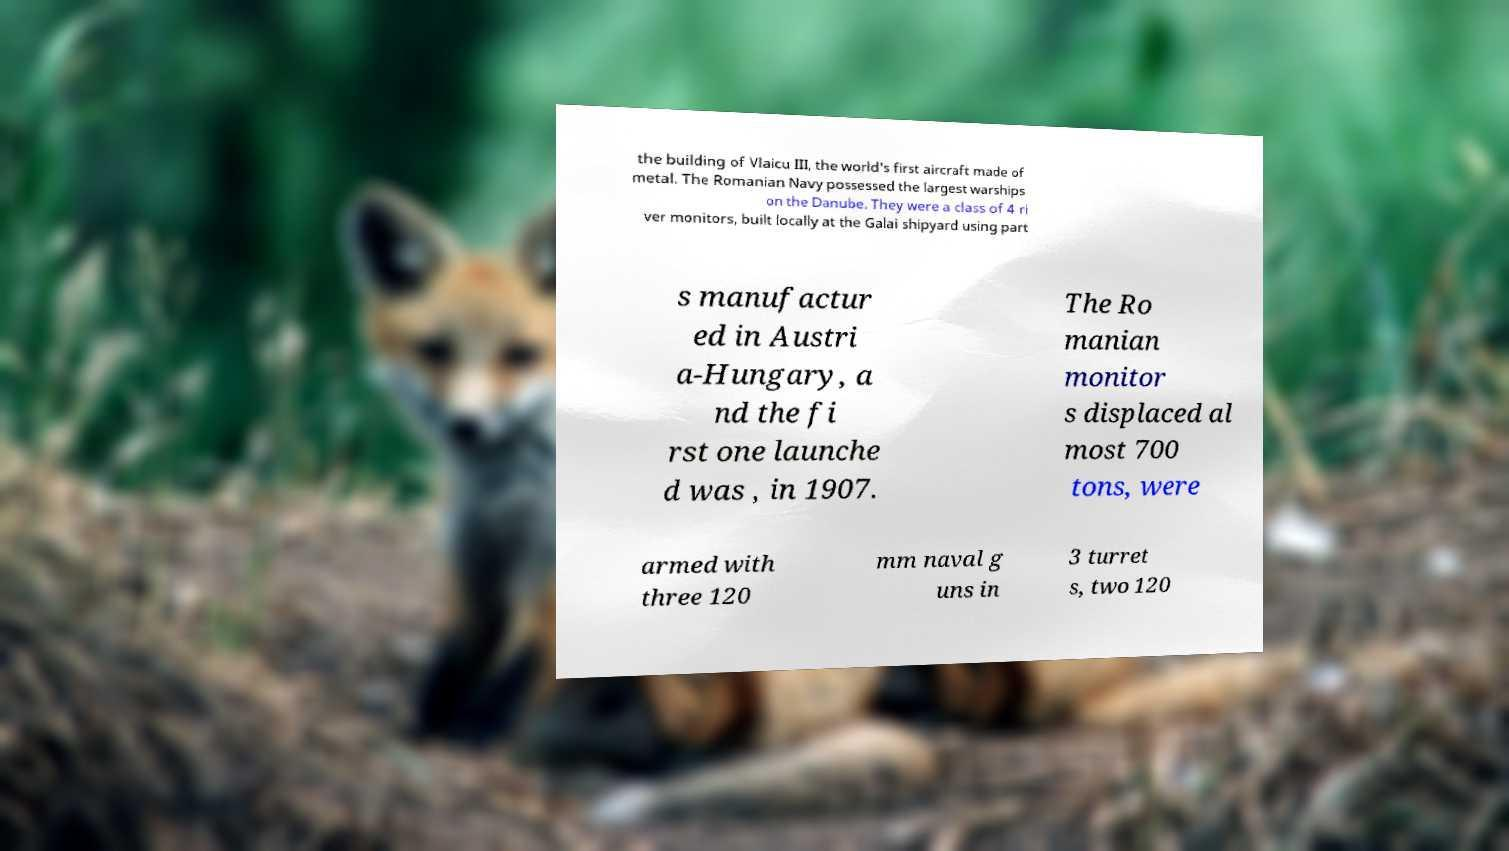Please identify and transcribe the text found in this image. the building of Vlaicu III, the world's first aircraft made of metal. The Romanian Navy possessed the largest warships on the Danube. They were a class of 4 ri ver monitors, built locally at the Galai shipyard using part s manufactur ed in Austri a-Hungary, a nd the fi rst one launche d was , in 1907. The Ro manian monitor s displaced al most 700 tons, were armed with three 120 mm naval g uns in 3 turret s, two 120 